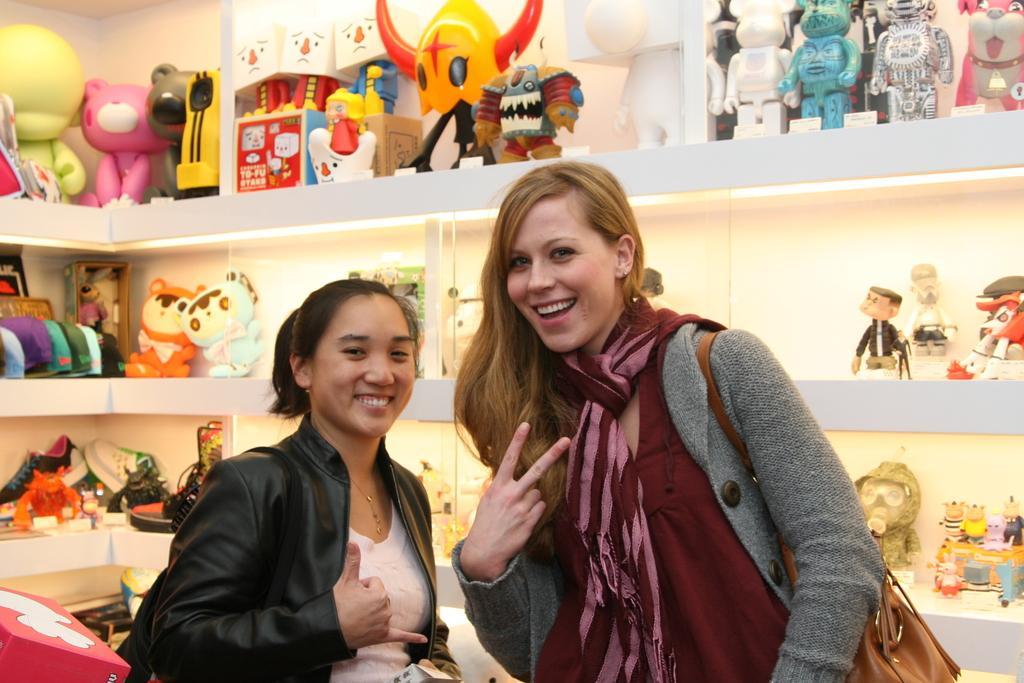Please provide a concise description of this image. In this picture, there are two women. A woman towards the left, she is wearing a black jacket. Towards the right, there is another woman, she is wearing a grey jacket, pink scarf and carrying a bag. In the background, there are shelves filled with the toys. 